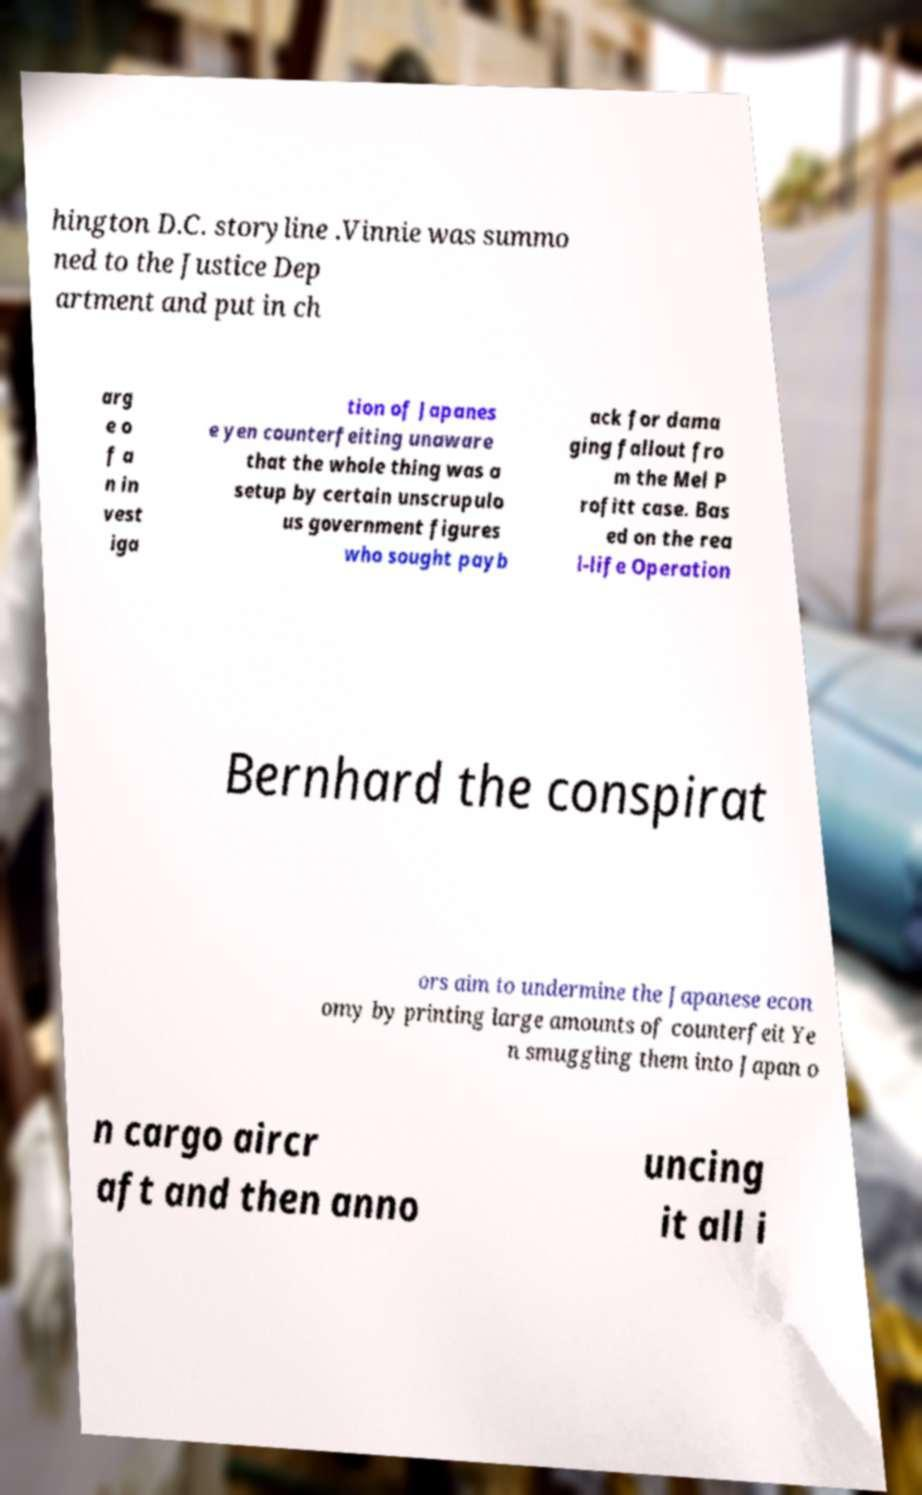Can you accurately transcribe the text from the provided image for me? hington D.C. storyline .Vinnie was summo ned to the Justice Dep artment and put in ch arg e o f a n in vest iga tion of Japanes e yen counterfeiting unaware that the whole thing was a setup by certain unscrupulo us government figures who sought payb ack for dama ging fallout fro m the Mel P rofitt case. Bas ed on the rea l-life Operation Bernhard the conspirat ors aim to undermine the Japanese econ omy by printing large amounts of counterfeit Ye n smuggling them into Japan o n cargo aircr aft and then anno uncing it all i 